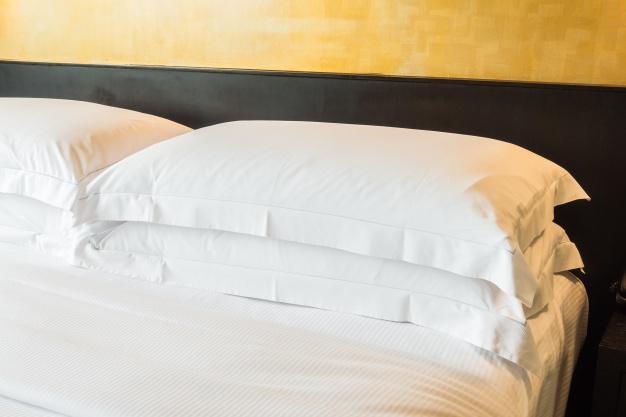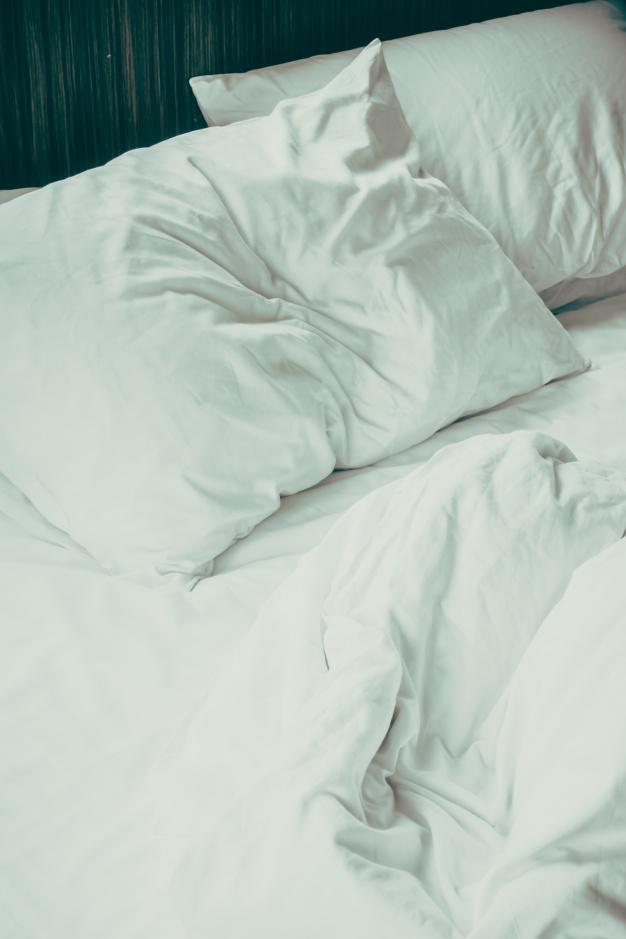The first image is the image on the left, the second image is the image on the right. Given the left and right images, does the statement "One image shows a bed with all white bedding in front of a brown headboard and matching drape." hold true? Answer yes or no. No. 